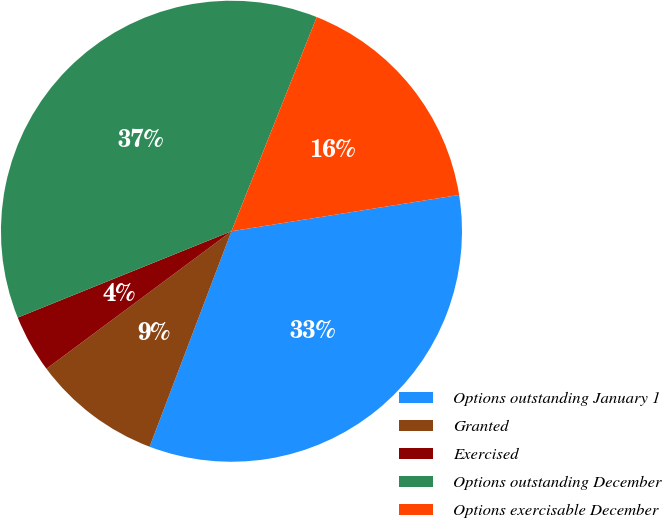Convert chart to OTSL. <chart><loc_0><loc_0><loc_500><loc_500><pie_chart><fcel>Options outstanding January 1<fcel>Granted<fcel>Exercised<fcel>Options outstanding December<fcel>Options exercisable December<nl><fcel>33.29%<fcel>9.05%<fcel>4.06%<fcel>37.14%<fcel>16.45%<nl></chart> 